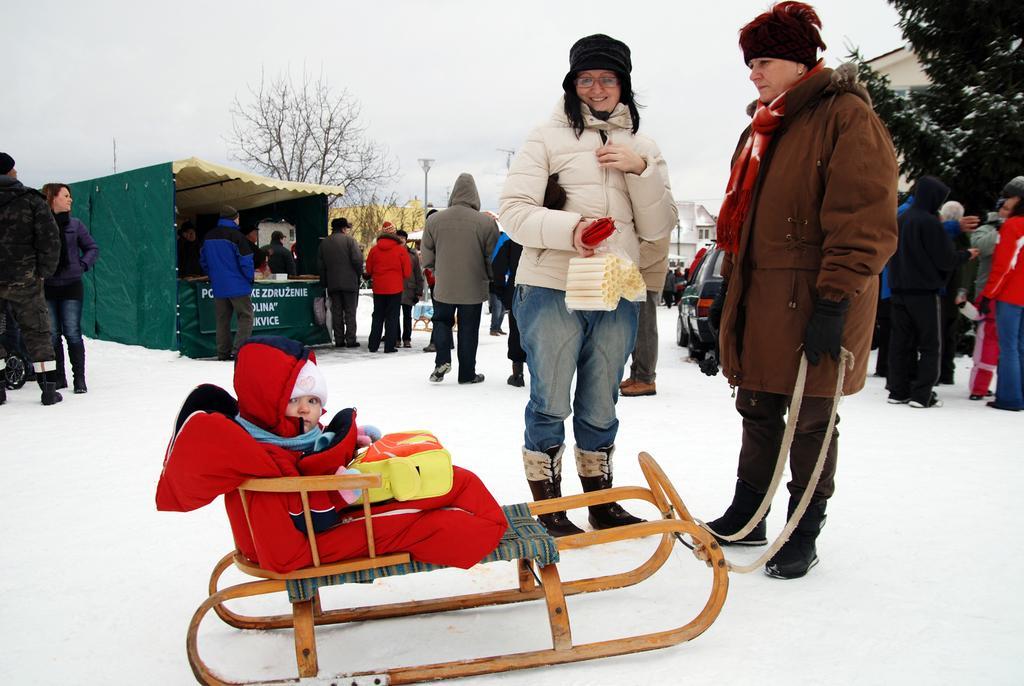How would you summarize this image in a sentence or two? In this picture I can see few people are standing and I can see buildings, trees and a baby on the cart and I can see snow on the ground and I can see text and a cloudy sky. 